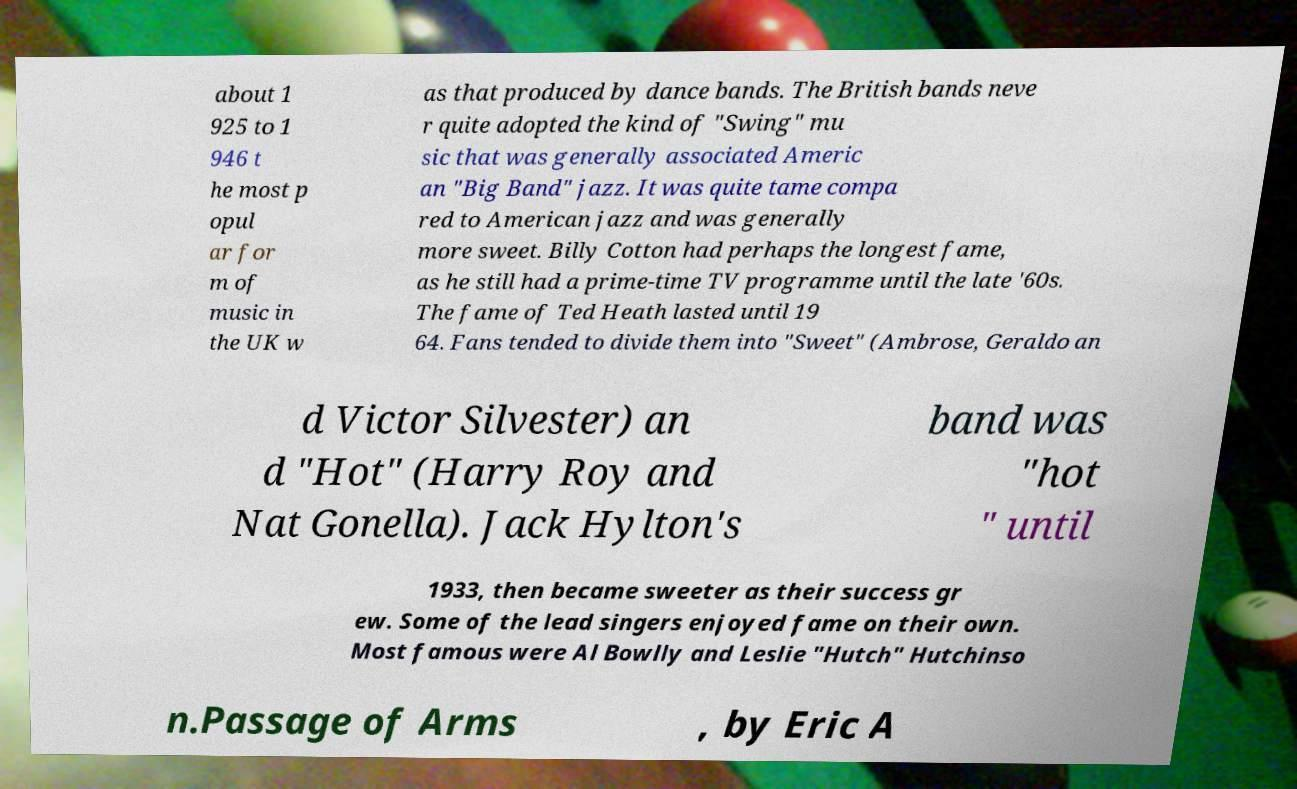There's text embedded in this image that I need extracted. Can you transcribe it verbatim? about 1 925 to 1 946 t he most p opul ar for m of music in the UK w as that produced by dance bands. The British bands neve r quite adopted the kind of "Swing" mu sic that was generally associated Americ an "Big Band" jazz. It was quite tame compa red to American jazz and was generally more sweet. Billy Cotton had perhaps the longest fame, as he still had a prime-time TV programme until the late '60s. The fame of Ted Heath lasted until 19 64. Fans tended to divide them into "Sweet" (Ambrose, Geraldo an d Victor Silvester) an d "Hot" (Harry Roy and Nat Gonella). Jack Hylton's band was "hot " until 1933, then became sweeter as their success gr ew. Some of the lead singers enjoyed fame on their own. Most famous were Al Bowlly and Leslie "Hutch" Hutchinso n.Passage of Arms , by Eric A 